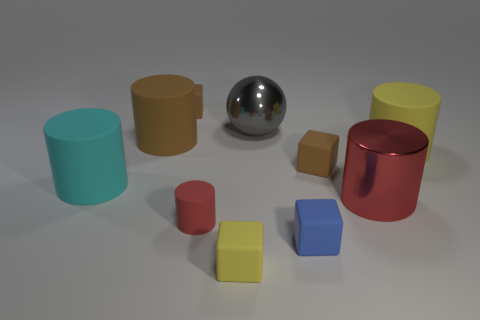Subtract all brown cylinders. How many cylinders are left? 4 Subtract all shiny cylinders. How many cylinders are left? 4 Subtract 2 cylinders. How many cylinders are left? 3 Subtract all blue cylinders. Subtract all red blocks. How many cylinders are left? 5 Subtract all spheres. How many objects are left? 9 Add 2 brown cubes. How many brown cubes are left? 4 Add 3 rubber cubes. How many rubber cubes exist? 7 Subtract 0 green spheres. How many objects are left? 10 Subtract all large rubber cylinders. Subtract all large red objects. How many objects are left? 6 